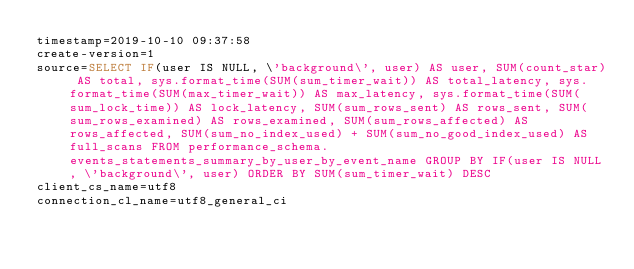<code> <loc_0><loc_0><loc_500><loc_500><_VisualBasic_>timestamp=2019-10-10 09:37:58
create-version=1
source=SELECT IF(user IS NULL, \'background\', user) AS user, SUM(count_star) AS total, sys.format_time(SUM(sum_timer_wait)) AS total_latency, sys.format_time(SUM(max_timer_wait)) AS max_latency, sys.format_time(SUM(sum_lock_time)) AS lock_latency, SUM(sum_rows_sent) AS rows_sent, SUM(sum_rows_examined) AS rows_examined, SUM(sum_rows_affected) AS rows_affected, SUM(sum_no_index_used) + SUM(sum_no_good_index_used) AS full_scans FROM performance_schema.events_statements_summary_by_user_by_event_name GROUP BY IF(user IS NULL, \'background\', user) ORDER BY SUM(sum_timer_wait) DESC
client_cs_name=utf8
connection_cl_name=utf8_general_ci</code> 